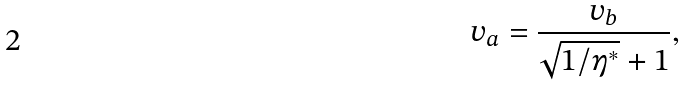<formula> <loc_0><loc_0><loc_500><loc_500>v _ { a } = \frac { v _ { b } } { \sqrt { 1 / \eta ^ { * } } + 1 } ,</formula> 